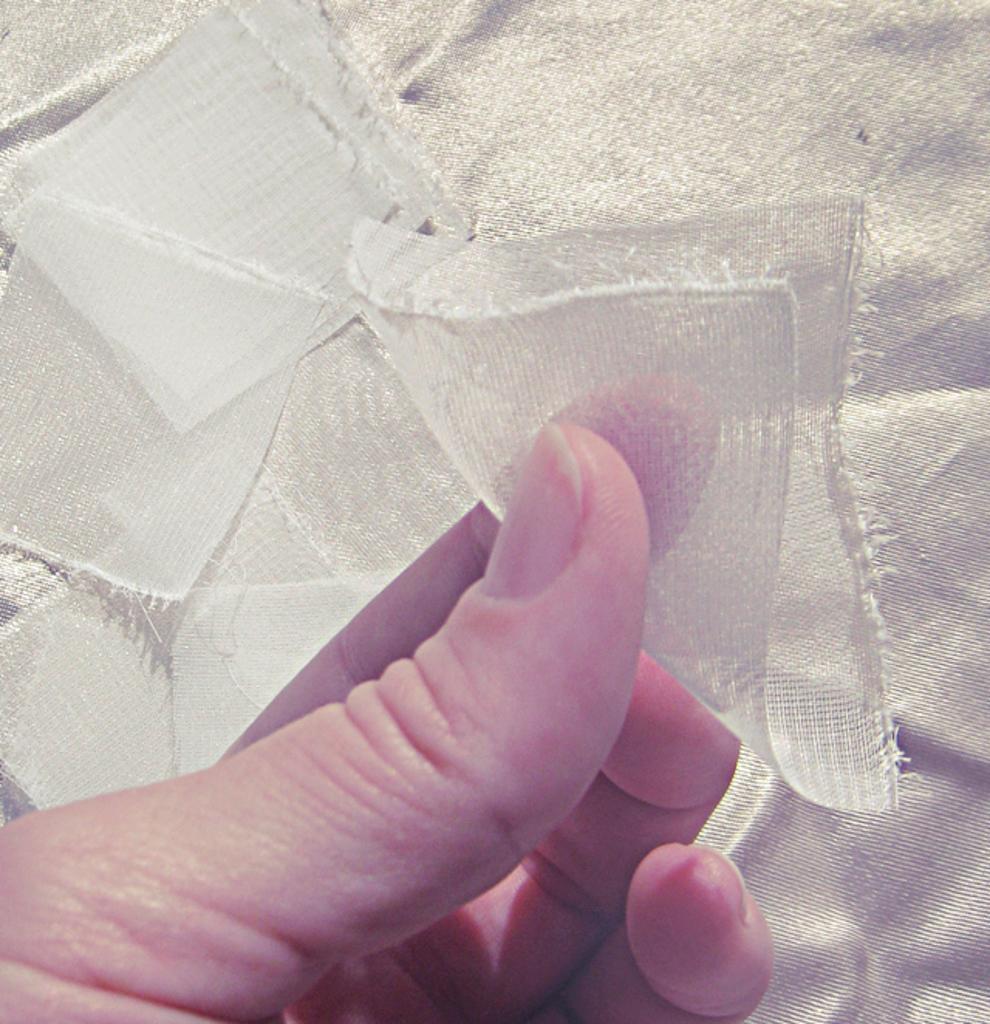Describe this image in one or two sentences. In the center of the image we can see pieces of cloth in person's hand. 